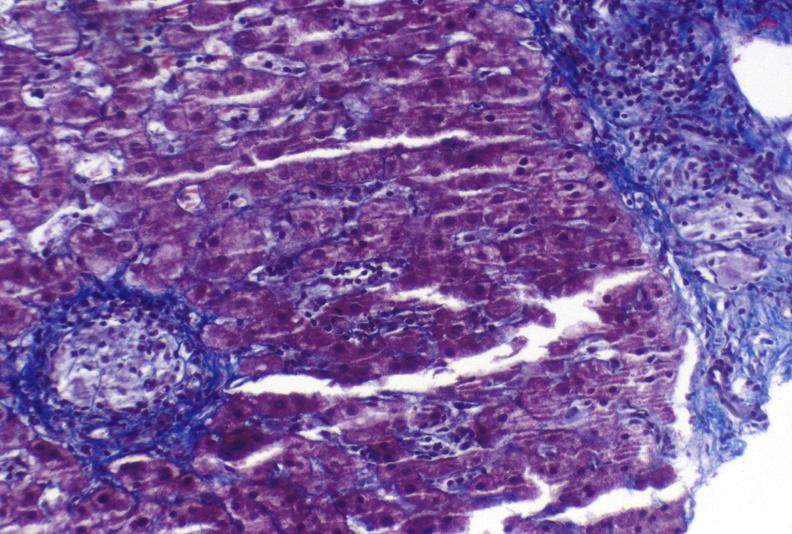what is present?
Answer the question using a single word or phrase. Liver 